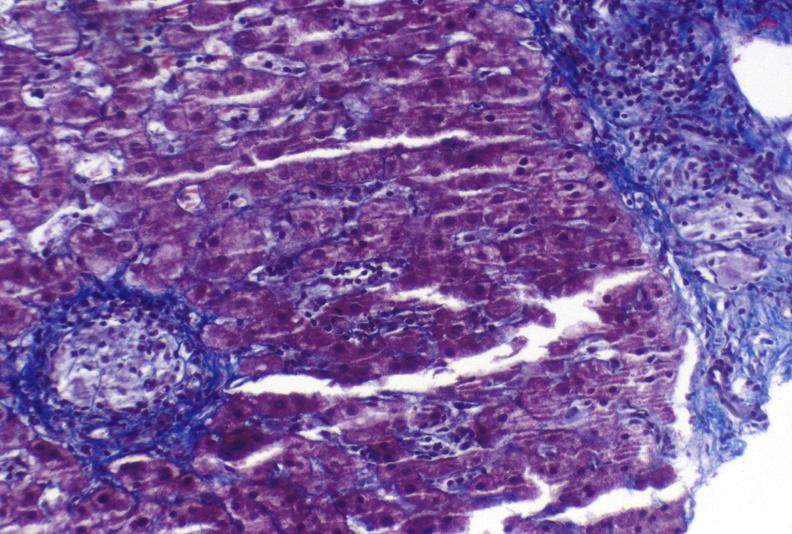what is present?
Answer the question using a single word or phrase. Liver 